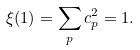Convert formula to latex. <formula><loc_0><loc_0><loc_500><loc_500>\xi ( 1 ) = \sum _ { p } c _ { p } ^ { 2 } = 1 .</formula> 